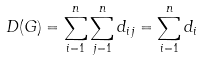Convert formula to latex. <formula><loc_0><loc_0><loc_500><loc_500>D ( G ) = \sum _ { i = 1 } ^ { n } \sum _ { j = 1 } ^ { n } d _ { i j } = \sum _ { i = 1 } ^ { n } d _ { i }</formula> 